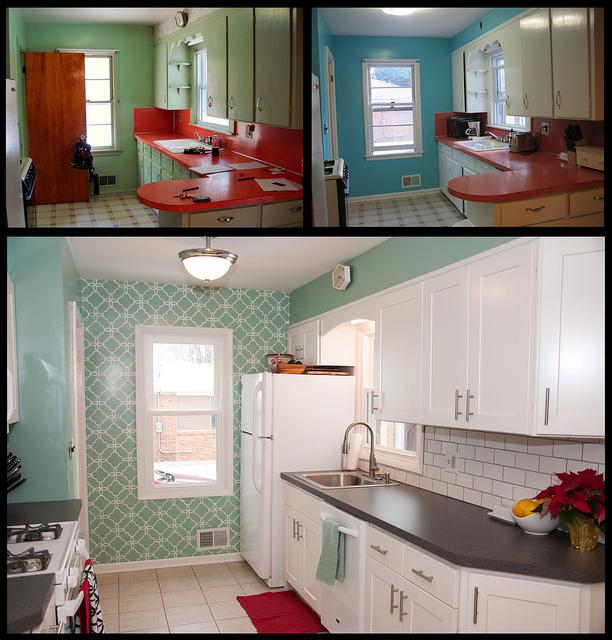Is there a microwave in this kitchen?
Short answer required. No. What color are the walls?
Answer briefly. Green. Are the rooms pictured the same room?
Concise answer only. Yes. Is the kitchen bright?
Be succinct. Yes. What room is pictured in each photo?
Be succinct. Kitchen. What color is the countertop in the bottom photo?
Short answer required. Black. Are all the tiles the same color?
Answer briefly. No. How many scenes are pictures here?
Quick response, please. 3. Is there a dishwasher in the photo?
Give a very brief answer. No. 